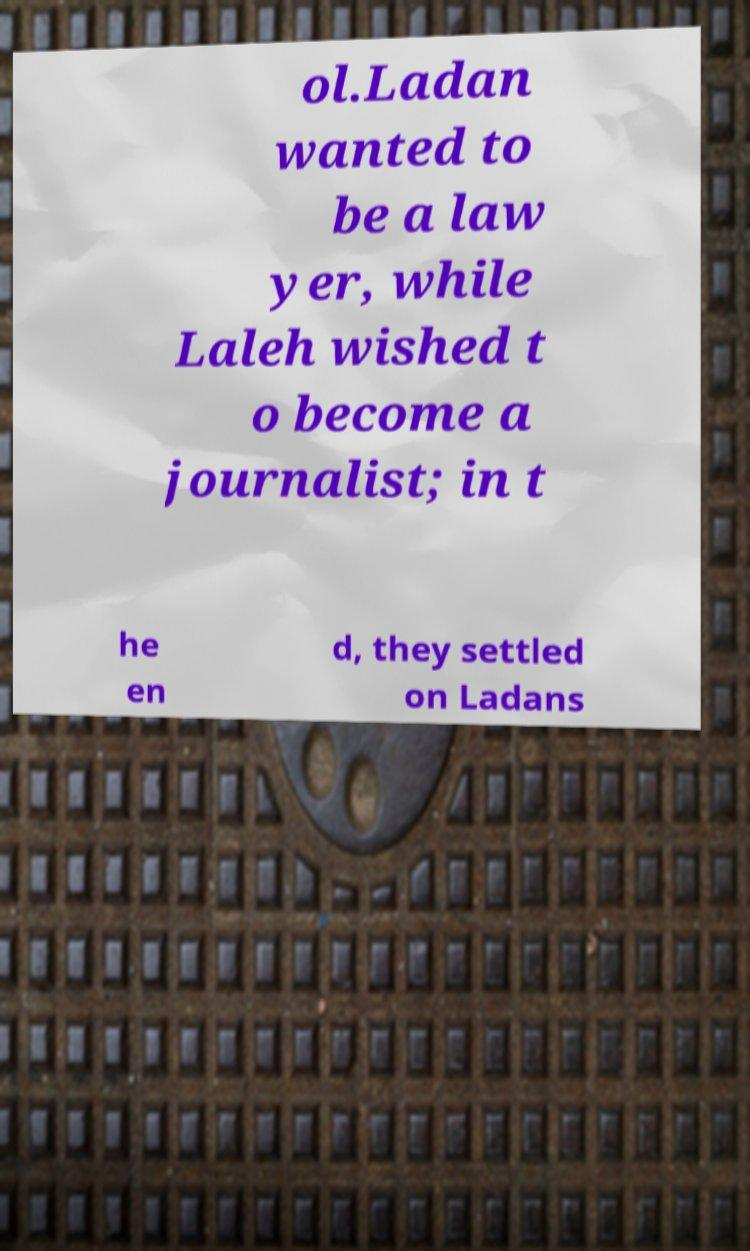Please read and relay the text visible in this image. What does it say? ol.Ladan wanted to be a law yer, while Laleh wished t o become a journalist; in t he en d, they settled on Ladans 